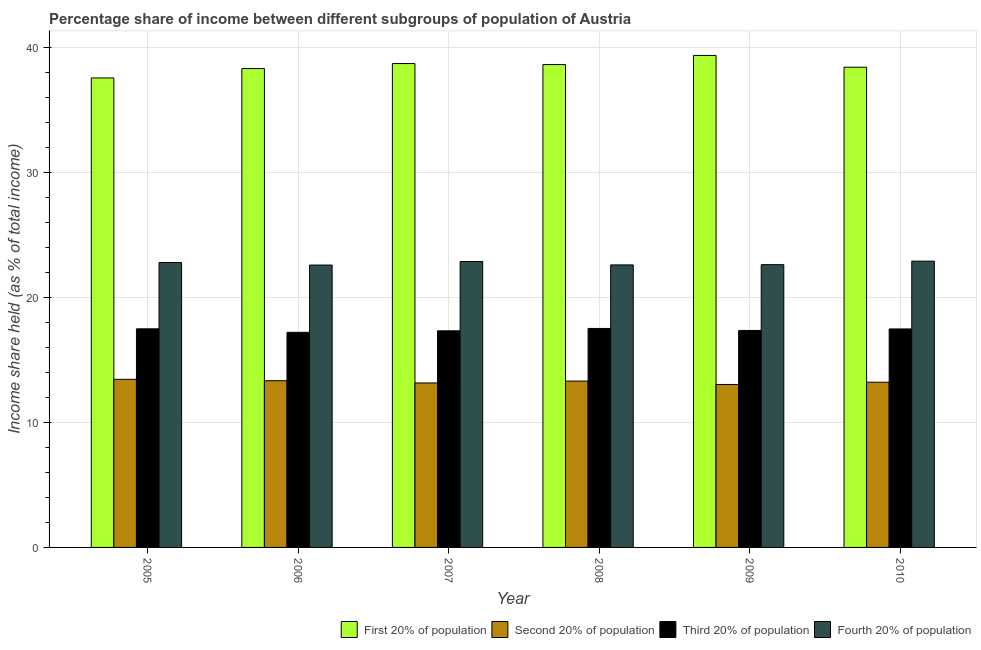Are the number of bars per tick equal to the number of legend labels?
Keep it short and to the point. Yes. Are the number of bars on each tick of the X-axis equal?
Give a very brief answer. Yes. In how many cases, is the number of bars for a given year not equal to the number of legend labels?
Ensure brevity in your answer.  0. What is the share of the income held by first 20% of the population in 2007?
Keep it short and to the point. 38.69. Across all years, what is the maximum share of the income held by fourth 20% of the population?
Offer a terse response. 22.89. Across all years, what is the minimum share of the income held by fourth 20% of the population?
Provide a succinct answer. 22.58. What is the total share of the income held by third 20% of the population in the graph?
Keep it short and to the point. 104.33. What is the difference between the share of the income held by third 20% of the population in 2005 and that in 2008?
Ensure brevity in your answer.  -0.03. What is the difference between the share of the income held by first 20% of the population in 2009 and the share of the income held by fourth 20% of the population in 2007?
Your answer should be very brief. 0.65. What is the average share of the income held by third 20% of the population per year?
Keep it short and to the point. 17.39. In the year 2005, what is the difference between the share of the income held by first 20% of the population and share of the income held by fourth 20% of the population?
Keep it short and to the point. 0. What is the ratio of the share of the income held by first 20% of the population in 2007 to that in 2008?
Ensure brevity in your answer.  1. Is the share of the income held by first 20% of the population in 2007 less than that in 2010?
Provide a short and direct response. No. Is the difference between the share of the income held by second 20% of the population in 2006 and 2008 greater than the difference between the share of the income held by third 20% of the population in 2006 and 2008?
Your answer should be very brief. No. What is the difference between the highest and the second highest share of the income held by third 20% of the population?
Make the answer very short. 0.03. What is the difference between the highest and the lowest share of the income held by third 20% of the population?
Offer a very short reply. 0.31. Is the sum of the share of the income held by first 20% of the population in 2007 and 2009 greater than the maximum share of the income held by second 20% of the population across all years?
Ensure brevity in your answer.  Yes. What does the 4th bar from the left in 2005 represents?
Ensure brevity in your answer.  Fourth 20% of population. What does the 4th bar from the right in 2005 represents?
Offer a terse response. First 20% of population. Are all the bars in the graph horizontal?
Your answer should be compact. No. What is the difference between two consecutive major ticks on the Y-axis?
Ensure brevity in your answer.  10. Where does the legend appear in the graph?
Provide a short and direct response. Bottom right. How many legend labels are there?
Provide a succinct answer. 4. What is the title of the graph?
Make the answer very short. Percentage share of income between different subgroups of population of Austria. What is the label or title of the X-axis?
Provide a succinct answer. Year. What is the label or title of the Y-axis?
Provide a succinct answer. Income share held (as % of total income). What is the Income share held (as % of total income) in First 20% of population in 2005?
Provide a succinct answer. 37.54. What is the Income share held (as % of total income) in Second 20% of population in 2005?
Provide a short and direct response. 13.44. What is the Income share held (as % of total income) of Third 20% of population in 2005?
Keep it short and to the point. 17.48. What is the Income share held (as % of total income) in Fourth 20% of population in 2005?
Offer a terse response. 22.78. What is the Income share held (as % of total income) of First 20% of population in 2006?
Offer a terse response. 38.29. What is the Income share held (as % of total income) of Second 20% of population in 2006?
Ensure brevity in your answer.  13.33. What is the Income share held (as % of total income) in Fourth 20% of population in 2006?
Provide a succinct answer. 22.58. What is the Income share held (as % of total income) in First 20% of population in 2007?
Give a very brief answer. 38.69. What is the Income share held (as % of total income) of Second 20% of population in 2007?
Keep it short and to the point. 13.15. What is the Income share held (as % of total income) in Third 20% of population in 2007?
Keep it short and to the point. 17.32. What is the Income share held (as % of total income) of Fourth 20% of population in 2007?
Offer a very short reply. 22.86. What is the Income share held (as % of total income) of First 20% of population in 2008?
Provide a succinct answer. 38.61. What is the Income share held (as % of total income) in Third 20% of population in 2008?
Make the answer very short. 17.51. What is the Income share held (as % of total income) in Fourth 20% of population in 2008?
Your answer should be compact. 22.59. What is the Income share held (as % of total income) in First 20% of population in 2009?
Your answer should be very brief. 39.34. What is the Income share held (as % of total income) of Second 20% of population in 2009?
Your answer should be very brief. 13.03. What is the Income share held (as % of total income) in Third 20% of population in 2009?
Make the answer very short. 17.35. What is the Income share held (as % of total income) in Fourth 20% of population in 2009?
Provide a succinct answer. 22.61. What is the Income share held (as % of total income) in First 20% of population in 2010?
Offer a very short reply. 38.4. What is the Income share held (as % of total income) of Second 20% of population in 2010?
Give a very brief answer. 13.21. What is the Income share held (as % of total income) in Third 20% of population in 2010?
Your response must be concise. 17.47. What is the Income share held (as % of total income) of Fourth 20% of population in 2010?
Your response must be concise. 22.89. Across all years, what is the maximum Income share held (as % of total income) of First 20% of population?
Provide a succinct answer. 39.34. Across all years, what is the maximum Income share held (as % of total income) of Second 20% of population?
Provide a short and direct response. 13.44. Across all years, what is the maximum Income share held (as % of total income) of Third 20% of population?
Your answer should be compact. 17.51. Across all years, what is the maximum Income share held (as % of total income) in Fourth 20% of population?
Keep it short and to the point. 22.89. Across all years, what is the minimum Income share held (as % of total income) in First 20% of population?
Your answer should be compact. 37.54. Across all years, what is the minimum Income share held (as % of total income) in Second 20% of population?
Your answer should be compact. 13.03. Across all years, what is the minimum Income share held (as % of total income) of Third 20% of population?
Provide a short and direct response. 17.2. Across all years, what is the minimum Income share held (as % of total income) of Fourth 20% of population?
Your response must be concise. 22.58. What is the total Income share held (as % of total income) in First 20% of population in the graph?
Provide a short and direct response. 230.87. What is the total Income share held (as % of total income) in Second 20% of population in the graph?
Your response must be concise. 79.46. What is the total Income share held (as % of total income) in Third 20% of population in the graph?
Offer a very short reply. 104.33. What is the total Income share held (as % of total income) of Fourth 20% of population in the graph?
Keep it short and to the point. 136.31. What is the difference between the Income share held (as % of total income) of First 20% of population in 2005 and that in 2006?
Provide a succinct answer. -0.75. What is the difference between the Income share held (as % of total income) of Second 20% of population in 2005 and that in 2006?
Your response must be concise. 0.11. What is the difference between the Income share held (as % of total income) of Third 20% of population in 2005 and that in 2006?
Make the answer very short. 0.28. What is the difference between the Income share held (as % of total income) in First 20% of population in 2005 and that in 2007?
Your response must be concise. -1.15. What is the difference between the Income share held (as % of total income) of Second 20% of population in 2005 and that in 2007?
Keep it short and to the point. 0.29. What is the difference between the Income share held (as % of total income) of Third 20% of population in 2005 and that in 2007?
Your response must be concise. 0.16. What is the difference between the Income share held (as % of total income) of Fourth 20% of population in 2005 and that in 2007?
Offer a terse response. -0.08. What is the difference between the Income share held (as % of total income) in First 20% of population in 2005 and that in 2008?
Keep it short and to the point. -1.07. What is the difference between the Income share held (as % of total income) in Second 20% of population in 2005 and that in 2008?
Provide a succinct answer. 0.14. What is the difference between the Income share held (as % of total income) in Third 20% of population in 2005 and that in 2008?
Provide a short and direct response. -0.03. What is the difference between the Income share held (as % of total income) in Fourth 20% of population in 2005 and that in 2008?
Offer a terse response. 0.19. What is the difference between the Income share held (as % of total income) in First 20% of population in 2005 and that in 2009?
Offer a terse response. -1.8. What is the difference between the Income share held (as % of total income) of Second 20% of population in 2005 and that in 2009?
Give a very brief answer. 0.41. What is the difference between the Income share held (as % of total income) of Third 20% of population in 2005 and that in 2009?
Ensure brevity in your answer.  0.13. What is the difference between the Income share held (as % of total income) of Fourth 20% of population in 2005 and that in 2009?
Provide a succinct answer. 0.17. What is the difference between the Income share held (as % of total income) of First 20% of population in 2005 and that in 2010?
Your answer should be compact. -0.86. What is the difference between the Income share held (as % of total income) of Second 20% of population in 2005 and that in 2010?
Your answer should be very brief. 0.23. What is the difference between the Income share held (as % of total income) in Third 20% of population in 2005 and that in 2010?
Give a very brief answer. 0.01. What is the difference between the Income share held (as % of total income) of Fourth 20% of population in 2005 and that in 2010?
Offer a terse response. -0.11. What is the difference between the Income share held (as % of total income) of First 20% of population in 2006 and that in 2007?
Your answer should be compact. -0.4. What is the difference between the Income share held (as % of total income) of Second 20% of population in 2006 and that in 2007?
Keep it short and to the point. 0.18. What is the difference between the Income share held (as % of total income) of Third 20% of population in 2006 and that in 2007?
Your answer should be compact. -0.12. What is the difference between the Income share held (as % of total income) in Fourth 20% of population in 2006 and that in 2007?
Offer a very short reply. -0.28. What is the difference between the Income share held (as % of total income) in First 20% of population in 2006 and that in 2008?
Your response must be concise. -0.32. What is the difference between the Income share held (as % of total income) of Second 20% of population in 2006 and that in 2008?
Keep it short and to the point. 0.03. What is the difference between the Income share held (as % of total income) of Third 20% of population in 2006 and that in 2008?
Your answer should be very brief. -0.31. What is the difference between the Income share held (as % of total income) in Fourth 20% of population in 2006 and that in 2008?
Provide a succinct answer. -0.01. What is the difference between the Income share held (as % of total income) of First 20% of population in 2006 and that in 2009?
Your answer should be very brief. -1.05. What is the difference between the Income share held (as % of total income) of Third 20% of population in 2006 and that in 2009?
Your answer should be compact. -0.15. What is the difference between the Income share held (as % of total income) of Fourth 20% of population in 2006 and that in 2009?
Provide a short and direct response. -0.03. What is the difference between the Income share held (as % of total income) in First 20% of population in 2006 and that in 2010?
Keep it short and to the point. -0.11. What is the difference between the Income share held (as % of total income) of Second 20% of population in 2006 and that in 2010?
Keep it short and to the point. 0.12. What is the difference between the Income share held (as % of total income) of Third 20% of population in 2006 and that in 2010?
Offer a terse response. -0.27. What is the difference between the Income share held (as % of total income) in Fourth 20% of population in 2006 and that in 2010?
Offer a very short reply. -0.31. What is the difference between the Income share held (as % of total income) in First 20% of population in 2007 and that in 2008?
Your answer should be compact. 0.08. What is the difference between the Income share held (as % of total income) in Third 20% of population in 2007 and that in 2008?
Your answer should be very brief. -0.19. What is the difference between the Income share held (as % of total income) in Fourth 20% of population in 2007 and that in 2008?
Provide a short and direct response. 0.27. What is the difference between the Income share held (as % of total income) of First 20% of population in 2007 and that in 2009?
Offer a terse response. -0.65. What is the difference between the Income share held (as % of total income) of Second 20% of population in 2007 and that in 2009?
Provide a succinct answer. 0.12. What is the difference between the Income share held (as % of total income) in Third 20% of population in 2007 and that in 2009?
Offer a terse response. -0.03. What is the difference between the Income share held (as % of total income) in Fourth 20% of population in 2007 and that in 2009?
Make the answer very short. 0.25. What is the difference between the Income share held (as % of total income) in First 20% of population in 2007 and that in 2010?
Provide a succinct answer. 0.29. What is the difference between the Income share held (as % of total income) of Second 20% of population in 2007 and that in 2010?
Ensure brevity in your answer.  -0.06. What is the difference between the Income share held (as % of total income) of Fourth 20% of population in 2007 and that in 2010?
Provide a short and direct response. -0.03. What is the difference between the Income share held (as % of total income) in First 20% of population in 2008 and that in 2009?
Your answer should be compact. -0.73. What is the difference between the Income share held (as % of total income) in Second 20% of population in 2008 and that in 2009?
Offer a terse response. 0.27. What is the difference between the Income share held (as % of total income) in Third 20% of population in 2008 and that in 2009?
Your response must be concise. 0.16. What is the difference between the Income share held (as % of total income) of Fourth 20% of population in 2008 and that in 2009?
Offer a terse response. -0.02. What is the difference between the Income share held (as % of total income) in First 20% of population in 2008 and that in 2010?
Provide a succinct answer. 0.21. What is the difference between the Income share held (as % of total income) of Second 20% of population in 2008 and that in 2010?
Give a very brief answer. 0.09. What is the difference between the Income share held (as % of total income) of Third 20% of population in 2008 and that in 2010?
Offer a very short reply. 0.04. What is the difference between the Income share held (as % of total income) of First 20% of population in 2009 and that in 2010?
Your response must be concise. 0.94. What is the difference between the Income share held (as % of total income) of Second 20% of population in 2009 and that in 2010?
Your answer should be compact. -0.18. What is the difference between the Income share held (as % of total income) in Third 20% of population in 2009 and that in 2010?
Your answer should be very brief. -0.12. What is the difference between the Income share held (as % of total income) in Fourth 20% of population in 2009 and that in 2010?
Provide a short and direct response. -0.28. What is the difference between the Income share held (as % of total income) of First 20% of population in 2005 and the Income share held (as % of total income) of Second 20% of population in 2006?
Provide a short and direct response. 24.21. What is the difference between the Income share held (as % of total income) in First 20% of population in 2005 and the Income share held (as % of total income) in Third 20% of population in 2006?
Your answer should be compact. 20.34. What is the difference between the Income share held (as % of total income) of First 20% of population in 2005 and the Income share held (as % of total income) of Fourth 20% of population in 2006?
Keep it short and to the point. 14.96. What is the difference between the Income share held (as % of total income) of Second 20% of population in 2005 and the Income share held (as % of total income) of Third 20% of population in 2006?
Your response must be concise. -3.76. What is the difference between the Income share held (as % of total income) in Second 20% of population in 2005 and the Income share held (as % of total income) in Fourth 20% of population in 2006?
Give a very brief answer. -9.14. What is the difference between the Income share held (as % of total income) of First 20% of population in 2005 and the Income share held (as % of total income) of Second 20% of population in 2007?
Make the answer very short. 24.39. What is the difference between the Income share held (as % of total income) of First 20% of population in 2005 and the Income share held (as % of total income) of Third 20% of population in 2007?
Your answer should be very brief. 20.22. What is the difference between the Income share held (as % of total income) of First 20% of population in 2005 and the Income share held (as % of total income) of Fourth 20% of population in 2007?
Offer a terse response. 14.68. What is the difference between the Income share held (as % of total income) of Second 20% of population in 2005 and the Income share held (as % of total income) of Third 20% of population in 2007?
Provide a short and direct response. -3.88. What is the difference between the Income share held (as % of total income) in Second 20% of population in 2005 and the Income share held (as % of total income) in Fourth 20% of population in 2007?
Give a very brief answer. -9.42. What is the difference between the Income share held (as % of total income) of Third 20% of population in 2005 and the Income share held (as % of total income) of Fourth 20% of population in 2007?
Offer a terse response. -5.38. What is the difference between the Income share held (as % of total income) in First 20% of population in 2005 and the Income share held (as % of total income) in Second 20% of population in 2008?
Keep it short and to the point. 24.24. What is the difference between the Income share held (as % of total income) of First 20% of population in 2005 and the Income share held (as % of total income) of Third 20% of population in 2008?
Ensure brevity in your answer.  20.03. What is the difference between the Income share held (as % of total income) of First 20% of population in 2005 and the Income share held (as % of total income) of Fourth 20% of population in 2008?
Your response must be concise. 14.95. What is the difference between the Income share held (as % of total income) of Second 20% of population in 2005 and the Income share held (as % of total income) of Third 20% of population in 2008?
Your answer should be compact. -4.07. What is the difference between the Income share held (as % of total income) of Second 20% of population in 2005 and the Income share held (as % of total income) of Fourth 20% of population in 2008?
Offer a terse response. -9.15. What is the difference between the Income share held (as % of total income) of Third 20% of population in 2005 and the Income share held (as % of total income) of Fourth 20% of population in 2008?
Make the answer very short. -5.11. What is the difference between the Income share held (as % of total income) in First 20% of population in 2005 and the Income share held (as % of total income) in Second 20% of population in 2009?
Offer a terse response. 24.51. What is the difference between the Income share held (as % of total income) of First 20% of population in 2005 and the Income share held (as % of total income) of Third 20% of population in 2009?
Your response must be concise. 20.19. What is the difference between the Income share held (as % of total income) of First 20% of population in 2005 and the Income share held (as % of total income) of Fourth 20% of population in 2009?
Offer a terse response. 14.93. What is the difference between the Income share held (as % of total income) in Second 20% of population in 2005 and the Income share held (as % of total income) in Third 20% of population in 2009?
Make the answer very short. -3.91. What is the difference between the Income share held (as % of total income) of Second 20% of population in 2005 and the Income share held (as % of total income) of Fourth 20% of population in 2009?
Keep it short and to the point. -9.17. What is the difference between the Income share held (as % of total income) of Third 20% of population in 2005 and the Income share held (as % of total income) of Fourth 20% of population in 2009?
Give a very brief answer. -5.13. What is the difference between the Income share held (as % of total income) in First 20% of population in 2005 and the Income share held (as % of total income) in Second 20% of population in 2010?
Make the answer very short. 24.33. What is the difference between the Income share held (as % of total income) in First 20% of population in 2005 and the Income share held (as % of total income) in Third 20% of population in 2010?
Provide a short and direct response. 20.07. What is the difference between the Income share held (as % of total income) in First 20% of population in 2005 and the Income share held (as % of total income) in Fourth 20% of population in 2010?
Your answer should be very brief. 14.65. What is the difference between the Income share held (as % of total income) in Second 20% of population in 2005 and the Income share held (as % of total income) in Third 20% of population in 2010?
Your answer should be compact. -4.03. What is the difference between the Income share held (as % of total income) in Second 20% of population in 2005 and the Income share held (as % of total income) in Fourth 20% of population in 2010?
Offer a very short reply. -9.45. What is the difference between the Income share held (as % of total income) in Third 20% of population in 2005 and the Income share held (as % of total income) in Fourth 20% of population in 2010?
Your answer should be very brief. -5.41. What is the difference between the Income share held (as % of total income) in First 20% of population in 2006 and the Income share held (as % of total income) in Second 20% of population in 2007?
Provide a short and direct response. 25.14. What is the difference between the Income share held (as % of total income) in First 20% of population in 2006 and the Income share held (as % of total income) in Third 20% of population in 2007?
Your response must be concise. 20.97. What is the difference between the Income share held (as % of total income) of First 20% of population in 2006 and the Income share held (as % of total income) of Fourth 20% of population in 2007?
Your answer should be compact. 15.43. What is the difference between the Income share held (as % of total income) in Second 20% of population in 2006 and the Income share held (as % of total income) in Third 20% of population in 2007?
Make the answer very short. -3.99. What is the difference between the Income share held (as % of total income) in Second 20% of population in 2006 and the Income share held (as % of total income) in Fourth 20% of population in 2007?
Keep it short and to the point. -9.53. What is the difference between the Income share held (as % of total income) of Third 20% of population in 2006 and the Income share held (as % of total income) of Fourth 20% of population in 2007?
Ensure brevity in your answer.  -5.66. What is the difference between the Income share held (as % of total income) of First 20% of population in 2006 and the Income share held (as % of total income) of Second 20% of population in 2008?
Ensure brevity in your answer.  24.99. What is the difference between the Income share held (as % of total income) in First 20% of population in 2006 and the Income share held (as % of total income) in Third 20% of population in 2008?
Offer a very short reply. 20.78. What is the difference between the Income share held (as % of total income) of First 20% of population in 2006 and the Income share held (as % of total income) of Fourth 20% of population in 2008?
Your answer should be compact. 15.7. What is the difference between the Income share held (as % of total income) in Second 20% of population in 2006 and the Income share held (as % of total income) in Third 20% of population in 2008?
Your answer should be very brief. -4.18. What is the difference between the Income share held (as % of total income) in Second 20% of population in 2006 and the Income share held (as % of total income) in Fourth 20% of population in 2008?
Offer a terse response. -9.26. What is the difference between the Income share held (as % of total income) of Third 20% of population in 2006 and the Income share held (as % of total income) of Fourth 20% of population in 2008?
Offer a very short reply. -5.39. What is the difference between the Income share held (as % of total income) in First 20% of population in 2006 and the Income share held (as % of total income) in Second 20% of population in 2009?
Provide a succinct answer. 25.26. What is the difference between the Income share held (as % of total income) in First 20% of population in 2006 and the Income share held (as % of total income) in Third 20% of population in 2009?
Offer a terse response. 20.94. What is the difference between the Income share held (as % of total income) of First 20% of population in 2006 and the Income share held (as % of total income) of Fourth 20% of population in 2009?
Your response must be concise. 15.68. What is the difference between the Income share held (as % of total income) of Second 20% of population in 2006 and the Income share held (as % of total income) of Third 20% of population in 2009?
Offer a terse response. -4.02. What is the difference between the Income share held (as % of total income) of Second 20% of population in 2006 and the Income share held (as % of total income) of Fourth 20% of population in 2009?
Ensure brevity in your answer.  -9.28. What is the difference between the Income share held (as % of total income) in Third 20% of population in 2006 and the Income share held (as % of total income) in Fourth 20% of population in 2009?
Offer a terse response. -5.41. What is the difference between the Income share held (as % of total income) in First 20% of population in 2006 and the Income share held (as % of total income) in Second 20% of population in 2010?
Provide a short and direct response. 25.08. What is the difference between the Income share held (as % of total income) in First 20% of population in 2006 and the Income share held (as % of total income) in Third 20% of population in 2010?
Ensure brevity in your answer.  20.82. What is the difference between the Income share held (as % of total income) of Second 20% of population in 2006 and the Income share held (as % of total income) of Third 20% of population in 2010?
Your response must be concise. -4.14. What is the difference between the Income share held (as % of total income) in Second 20% of population in 2006 and the Income share held (as % of total income) in Fourth 20% of population in 2010?
Your response must be concise. -9.56. What is the difference between the Income share held (as % of total income) of Third 20% of population in 2006 and the Income share held (as % of total income) of Fourth 20% of population in 2010?
Your answer should be compact. -5.69. What is the difference between the Income share held (as % of total income) in First 20% of population in 2007 and the Income share held (as % of total income) in Second 20% of population in 2008?
Your answer should be compact. 25.39. What is the difference between the Income share held (as % of total income) in First 20% of population in 2007 and the Income share held (as % of total income) in Third 20% of population in 2008?
Your response must be concise. 21.18. What is the difference between the Income share held (as % of total income) of First 20% of population in 2007 and the Income share held (as % of total income) of Fourth 20% of population in 2008?
Offer a terse response. 16.1. What is the difference between the Income share held (as % of total income) of Second 20% of population in 2007 and the Income share held (as % of total income) of Third 20% of population in 2008?
Your response must be concise. -4.36. What is the difference between the Income share held (as % of total income) of Second 20% of population in 2007 and the Income share held (as % of total income) of Fourth 20% of population in 2008?
Offer a very short reply. -9.44. What is the difference between the Income share held (as % of total income) of Third 20% of population in 2007 and the Income share held (as % of total income) of Fourth 20% of population in 2008?
Provide a succinct answer. -5.27. What is the difference between the Income share held (as % of total income) in First 20% of population in 2007 and the Income share held (as % of total income) in Second 20% of population in 2009?
Ensure brevity in your answer.  25.66. What is the difference between the Income share held (as % of total income) of First 20% of population in 2007 and the Income share held (as % of total income) of Third 20% of population in 2009?
Your answer should be compact. 21.34. What is the difference between the Income share held (as % of total income) of First 20% of population in 2007 and the Income share held (as % of total income) of Fourth 20% of population in 2009?
Provide a succinct answer. 16.08. What is the difference between the Income share held (as % of total income) in Second 20% of population in 2007 and the Income share held (as % of total income) in Fourth 20% of population in 2009?
Your answer should be compact. -9.46. What is the difference between the Income share held (as % of total income) in Third 20% of population in 2007 and the Income share held (as % of total income) in Fourth 20% of population in 2009?
Your response must be concise. -5.29. What is the difference between the Income share held (as % of total income) in First 20% of population in 2007 and the Income share held (as % of total income) in Second 20% of population in 2010?
Offer a terse response. 25.48. What is the difference between the Income share held (as % of total income) in First 20% of population in 2007 and the Income share held (as % of total income) in Third 20% of population in 2010?
Your response must be concise. 21.22. What is the difference between the Income share held (as % of total income) in First 20% of population in 2007 and the Income share held (as % of total income) in Fourth 20% of population in 2010?
Give a very brief answer. 15.8. What is the difference between the Income share held (as % of total income) of Second 20% of population in 2007 and the Income share held (as % of total income) of Third 20% of population in 2010?
Give a very brief answer. -4.32. What is the difference between the Income share held (as % of total income) in Second 20% of population in 2007 and the Income share held (as % of total income) in Fourth 20% of population in 2010?
Your answer should be compact. -9.74. What is the difference between the Income share held (as % of total income) in Third 20% of population in 2007 and the Income share held (as % of total income) in Fourth 20% of population in 2010?
Offer a very short reply. -5.57. What is the difference between the Income share held (as % of total income) of First 20% of population in 2008 and the Income share held (as % of total income) of Second 20% of population in 2009?
Offer a very short reply. 25.58. What is the difference between the Income share held (as % of total income) in First 20% of population in 2008 and the Income share held (as % of total income) in Third 20% of population in 2009?
Offer a very short reply. 21.26. What is the difference between the Income share held (as % of total income) of First 20% of population in 2008 and the Income share held (as % of total income) of Fourth 20% of population in 2009?
Offer a terse response. 16. What is the difference between the Income share held (as % of total income) in Second 20% of population in 2008 and the Income share held (as % of total income) in Third 20% of population in 2009?
Offer a very short reply. -4.05. What is the difference between the Income share held (as % of total income) of Second 20% of population in 2008 and the Income share held (as % of total income) of Fourth 20% of population in 2009?
Ensure brevity in your answer.  -9.31. What is the difference between the Income share held (as % of total income) in First 20% of population in 2008 and the Income share held (as % of total income) in Second 20% of population in 2010?
Make the answer very short. 25.4. What is the difference between the Income share held (as % of total income) in First 20% of population in 2008 and the Income share held (as % of total income) in Third 20% of population in 2010?
Your answer should be very brief. 21.14. What is the difference between the Income share held (as % of total income) of First 20% of population in 2008 and the Income share held (as % of total income) of Fourth 20% of population in 2010?
Provide a succinct answer. 15.72. What is the difference between the Income share held (as % of total income) in Second 20% of population in 2008 and the Income share held (as % of total income) in Third 20% of population in 2010?
Provide a short and direct response. -4.17. What is the difference between the Income share held (as % of total income) in Second 20% of population in 2008 and the Income share held (as % of total income) in Fourth 20% of population in 2010?
Provide a succinct answer. -9.59. What is the difference between the Income share held (as % of total income) of Third 20% of population in 2008 and the Income share held (as % of total income) of Fourth 20% of population in 2010?
Offer a very short reply. -5.38. What is the difference between the Income share held (as % of total income) in First 20% of population in 2009 and the Income share held (as % of total income) in Second 20% of population in 2010?
Your response must be concise. 26.13. What is the difference between the Income share held (as % of total income) in First 20% of population in 2009 and the Income share held (as % of total income) in Third 20% of population in 2010?
Keep it short and to the point. 21.87. What is the difference between the Income share held (as % of total income) in First 20% of population in 2009 and the Income share held (as % of total income) in Fourth 20% of population in 2010?
Ensure brevity in your answer.  16.45. What is the difference between the Income share held (as % of total income) in Second 20% of population in 2009 and the Income share held (as % of total income) in Third 20% of population in 2010?
Keep it short and to the point. -4.44. What is the difference between the Income share held (as % of total income) in Second 20% of population in 2009 and the Income share held (as % of total income) in Fourth 20% of population in 2010?
Ensure brevity in your answer.  -9.86. What is the difference between the Income share held (as % of total income) of Third 20% of population in 2009 and the Income share held (as % of total income) of Fourth 20% of population in 2010?
Make the answer very short. -5.54. What is the average Income share held (as % of total income) in First 20% of population per year?
Offer a terse response. 38.48. What is the average Income share held (as % of total income) of Second 20% of population per year?
Ensure brevity in your answer.  13.24. What is the average Income share held (as % of total income) in Third 20% of population per year?
Keep it short and to the point. 17.39. What is the average Income share held (as % of total income) of Fourth 20% of population per year?
Give a very brief answer. 22.72. In the year 2005, what is the difference between the Income share held (as % of total income) of First 20% of population and Income share held (as % of total income) of Second 20% of population?
Offer a very short reply. 24.1. In the year 2005, what is the difference between the Income share held (as % of total income) in First 20% of population and Income share held (as % of total income) in Third 20% of population?
Provide a succinct answer. 20.06. In the year 2005, what is the difference between the Income share held (as % of total income) of First 20% of population and Income share held (as % of total income) of Fourth 20% of population?
Give a very brief answer. 14.76. In the year 2005, what is the difference between the Income share held (as % of total income) in Second 20% of population and Income share held (as % of total income) in Third 20% of population?
Ensure brevity in your answer.  -4.04. In the year 2005, what is the difference between the Income share held (as % of total income) in Second 20% of population and Income share held (as % of total income) in Fourth 20% of population?
Provide a succinct answer. -9.34. In the year 2006, what is the difference between the Income share held (as % of total income) in First 20% of population and Income share held (as % of total income) in Second 20% of population?
Make the answer very short. 24.96. In the year 2006, what is the difference between the Income share held (as % of total income) of First 20% of population and Income share held (as % of total income) of Third 20% of population?
Offer a very short reply. 21.09. In the year 2006, what is the difference between the Income share held (as % of total income) in First 20% of population and Income share held (as % of total income) in Fourth 20% of population?
Your response must be concise. 15.71. In the year 2006, what is the difference between the Income share held (as % of total income) in Second 20% of population and Income share held (as % of total income) in Third 20% of population?
Offer a very short reply. -3.87. In the year 2006, what is the difference between the Income share held (as % of total income) in Second 20% of population and Income share held (as % of total income) in Fourth 20% of population?
Your answer should be very brief. -9.25. In the year 2006, what is the difference between the Income share held (as % of total income) of Third 20% of population and Income share held (as % of total income) of Fourth 20% of population?
Your response must be concise. -5.38. In the year 2007, what is the difference between the Income share held (as % of total income) of First 20% of population and Income share held (as % of total income) of Second 20% of population?
Provide a succinct answer. 25.54. In the year 2007, what is the difference between the Income share held (as % of total income) in First 20% of population and Income share held (as % of total income) in Third 20% of population?
Keep it short and to the point. 21.37. In the year 2007, what is the difference between the Income share held (as % of total income) in First 20% of population and Income share held (as % of total income) in Fourth 20% of population?
Your response must be concise. 15.83. In the year 2007, what is the difference between the Income share held (as % of total income) of Second 20% of population and Income share held (as % of total income) of Third 20% of population?
Provide a succinct answer. -4.17. In the year 2007, what is the difference between the Income share held (as % of total income) of Second 20% of population and Income share held (as % of total income) of Fourth 20% of population?
Your response must be concise. -9.71. In the year 2007, what is the difference between the Income share held (as % of total income) of Third 20% of population and Income share held (as % of total income) of Fourth 20% of population?
Give a very brief answer. -5.54. In the year 2008, what is the difference between the Income share held (as % of total income) of First 20% of population and Income share held (as % of total income) of Second 20% of population?
Make the answer very short. 25.31. In the year 2008, what is the difference between the Income share held (as % of total income) of First 20% of population and Income share held (as % of total income) of Third 20% of population?
Offer a very short reply. 21.1. In the year 2008, what is the difference between the Income share held (as % of total income) of First 20% of population and Income share held (as % of total income) of Fourth 20% of population?
Ensure brevity in your answer.  16.02. In the year 2008, what is the difference between the Income share held (as % of total income) of Second 20% of population and Income share held (as % of total income) of Third 20% of population?
Make the answer very short. -4.21. In the year 2008, what is the difference between the Income share held (as % of total income) of Second 20% of population and Income share held (as % of total income) of Fourth 20% of population?
Ensure brevity in your answer.  -9.29. In the year 2008, what is the difference between the Income share held (as % of total income) in Third 20% of population and Income share held (as % of total income) in Fourth 20% of population?
Ensure brevity in your answer.  -5.08. In the year 2009, what is the difference between the Income share held (as % of total income) in First 20% of population and Income share held (as % of total income) in Second 20% of population?
Make the answer very short. 26.31. In the year 2009, what is the difference between the Income share held (as % of total income) of First 20% of population and Income share held (as % of total income) of Third 20% of population?
Provide a succinct answer. 21.99. In the year 2009, what is the difference between the Income share held (as % of total income) in First 20% of population and Income share held (as % of total income) in Fourth 20% of population?
Offer a terse response. 16.73. In the year 2009, what is the difference between the Income share held (as % of total income) in Second 20% of population and Income share held (as % of total income) in Third 20% of population?
Your response must be concise. -4.32. In the year 2009, what is the difference between the Income share held (as % of total income) of Second 20% of population and Income share held (as % of total income) of Fourth 20% of population?
Make the answer very short. -9.58. In the year 2009, what is the difference between the Income share held (as % of total income) in Third 20% of population and Income share held (as % of total income) in Fourth 20% of population?
Your answer should be compact. -5.26. In the year 2010, what is the difference between the Income share held (as % of total income) in First 20% of population and Income share held (as % of total income) in Second 20% of population?
Offer a very short reply. 25.19. In the year 2010, what is the difference between the Income share held (as % of total income) in First 20% of population and Income share held (as % of total income) in Third 20% of population?
Keep it short and to the point. 20.93. In the year 2010, what is the difference between the Income share held (as % of total income) of First 20% of population and Income share held (as % of total income) of Fourth 20% of population?
Ensure brevity in your answer.  15.51. In the year 2010, what is the difference between the Income share held (as % of total income) in Second 20% of population and Income share held (as % of total income) in Third 20% of population?
Ensure brevity in your answer.  -4.26. In the year 2010, what is the difference between the Income share held (as % of total income) in Second 20% of population and Income share held (as % of total income) in Fourth 20% of population?
Provide a short and direct response. -9.68. In the year 2010, what is the difference between the Income share held (as % of total income) in Third 20% of population and Income share held (as % of total income) in Fourth 20% of population?
Ensure brevity in your answer.  -5.42. What is the ratio of the Income share held (as % of total income) in First 20% of population in 2005 to that in 2006?
Offer a very short reply. 0.98. What is the ratio of the Income share held (as % of total income) of Second 20% of population in 2005 to that in 2006?
Offer a very short reply. 1.01. What is the ratio of the Income share held (as % of total income) in Third 20% of population in 2005 to that in 2006?
Provide a succinct answer. 1.02. What is the ratio of the Income share held (as % of total income) of Fourth 20% of population in 2005 to that in 2006?
Offer a terse response. 1.01. What is the ratio of the Income share held (as % of total income) in First 20% of population in 2005 to that in 2007?
Your answer should be very brief. 0.97. What is the ratio of the Income share held (as % of total income) in Second 20% of population in 2005 to that in 2007?
Provide a short and direct response. 1.02. What is the ratio of the Income share held (as % of total income) in Third 20% of population in 2005 to that in 2007?
Provide a short and direct response. 1.01. What is the ratio of the Income share held (as % of total income) in First 20% of population in 2005 to that in 2008?
Your response must be concise. 0.97. What is the ratio of the Income share held (as % of total income) in Second 20% of population in 2005 to that in 2008?
Your response must be concise. 1.01. What is the ratio of the Income share held (as % of total income) of Third 20% of population in 2005 to that in 2008?
Keep it short and to the point. 1. What is the ratio of the Income share held (as % of total income) of Fourth 20% of population in 2005 to that in 2008?
Offer a very short reply. 1.01. What is the ratio of the Income share held (as % of total income) of First 20% of population in 2005 to that in 2009?
Your answer should be compact. 0.95. What is the ratio of the Income share held (as % of total income) of Second 20% of population in 2005 to that in 2009?
Provide a succinct answer. 1.03. What is the ratio of the Income share held (as % of total income) of Third 20% of population in 2005 to that in 2009?
Ensure brevity in your answer.  1.01. What is the ratio of the Income share held (as % of total income) of Fourth 20% of population in 2005 to that in 2009?
Offer a terse response. 1.01. What is the ratio of the Income share held (as % of total income) of First 20% of population in 2005 to that in 2010?
Offer a very short reply. 0.98. What is the ratio of the Income share held (as % of total income) in Second 20% of population in 2005 to that in 2010?
Ensure brevity in your answer.  1.02. What is the ratio of the Income share held (as % of total income) in Second 20% of population in 2006 to that in 2007?
Ensure brevity in your answer.  1.01. What is the ratio of the Income share held (as % of total income) in Fourth 20% of population in 2006 to that in 2007?
Keep it short and to the point. 0.99. What is the ratio of the Income share held (as % of total income) of First 20% of population in 2006 to that in 2008?
Your response must be concise. 0.99. What is the ratio of the Income share held (as % of total income) in Third 20% of population in 2006 to that in 2008?
Offer a terse response. 0.98. What is the ratio of the Income share held (as % of total income) of First 20% of population in 2006 to that in 2009?
Offer a terse response. 0.97. What is the ratio of the Income share held (as % of total income) of Second 20% of population in 2006 to that in 2009?
Make the answer very short. 1.02. What is the ratio of the Income share held (as % of total income) in Fourth 20% of population in 2006 to that in 2009?
Offer a terse response. 1. What is the ratio of the Income share held (as % of total income) of First 20% of population in 2006 to that in 2010?
Offer a terse response. 1. What is the ratio of the Income share held (as % of total income) of Second 20% of population in 2006 to that in 2010?
Provide a short and direct response. 1.01. What is the ratio of the Income share held (as % of total income) of Third 20% of population in 2006 to that in 2010?
Make the answer very short. 0.98. What is the ratio of the Income share held (as % of total income) of Fourth 20% of population in 2006 to that in 2010?
Ensure brevity in your answer.  0.99. What is the ratio of the Income share held (as % of total income) in Second 20% of population in 2007 to that in 2008?
Offer a terse response. 0.99. What is the ratio of the Income share held (as % of total income) of First 20% of population in 2007 to that in 2009?
Give a very brief answer. 0.98. What is the ratio of the Income share held (as % of total income) in Second 20% of population in 2007 to that in 2009?
Make the answer very short. 1.01. What is the ratio of the Income share held (as % of total income) in Fourth 20% of population in 2007 to that in 2009?
Your answer should be very brief. 1.01. What is the ratio of the Income share held (as % of total income) of First 20% of population in 2007 to that in 2010?
Offer a very short reply. 1.01. What is the ratio of the Income share held (as % of total income) of Second 20% of population in 2007 to that in 2010?
Provide a short and direct response. 1. What is the ratio of the Income share held (as % of total income) of Third 20% of population in 2007 to that in 2010?
Your answer should be very brief. 0.99. What is the ratio of the Income share held (as % of total income) in First 20% of population in 2008 to that in 2009?
Provide a succinct answer. 0.98. What is the ratio of the Income share held (as % of total income) in Second 20% of population in 2008 to that in 2009?
Your answer should be very brief. 1.02. What is the ratio of the Income share held (as % of total income) of Third 20% of population in 2008 to that in 2009?
Make the answer very short. 1.01. What is the ratio of the Income share held (as % of total income) in Second 20% of population in 2008 to that in 2010?
Offer a very short reply. 1.01. What is the ratio of the Income share held (as % of total income) in Third 20% of population in 2008 to that in 2010?
Offer a terse response. 1. What is the ratio of the Income share held (as % of total income) of Fourth 20% of population in 2008 to that in 2010?
Offer a terse response. 0.99. What is the ratio of the Income share held (as % of total income) of First 20% of population in 2009 to that in 2010?
Give a very brief answer. 1.02. What is the ratio of the Income share held (as % of total income) of Second 20% of population in 2009 to that in 2010?
Your answer should be very brief. 0.99. What is the ratio of the Income share held (as % of total income) in Third 20% of population in 2009 to that in 2010?
Ensure brevity in your answer.  0.99. What is the difference between the highest and the second highest Income share held (as % of total income) of First 20% of population?
Keep it short and to the point. 0.65. What is the difference between the highest and the second highest Income share held (as % of total income) of Second 20% of population?
Ensure brevity in your answer.  0.11. What is the difference between the highest and the second highest Income share held (as % of total income) in Third 20% of population?
Ensure brevity in your answer.  0.03. What is the difference between the highest and the second highest Income share held (as % of total income) of Fourth 20% of population?
Keep it short and to the point. 0.03. What is the difference between the highest and the lowest Income share held (as % of total income) in First 20% of population?
Ensure brevity in your answer.  1.8. What is the difference between the highest and the lowest Income share held (as % of total income) of Second 20% of population?
Your answer should be very brief. 0.41. What is the difference between the highest and the lowest Income share held (as % of total income) in Third 20% of population?
Your response must be concise. 0.31. What is the difference between the highest and the lowest Income share held (as % of total income) in Fourth 20% of population?
Your answer should be compact. 0.31. 